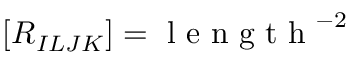Convert formula to latex. <formula><loc_0><loc_0><loc_500><loc_500>[ R _ { I L J K } ] = l e n g t h ^ { - 2 }</formula> 